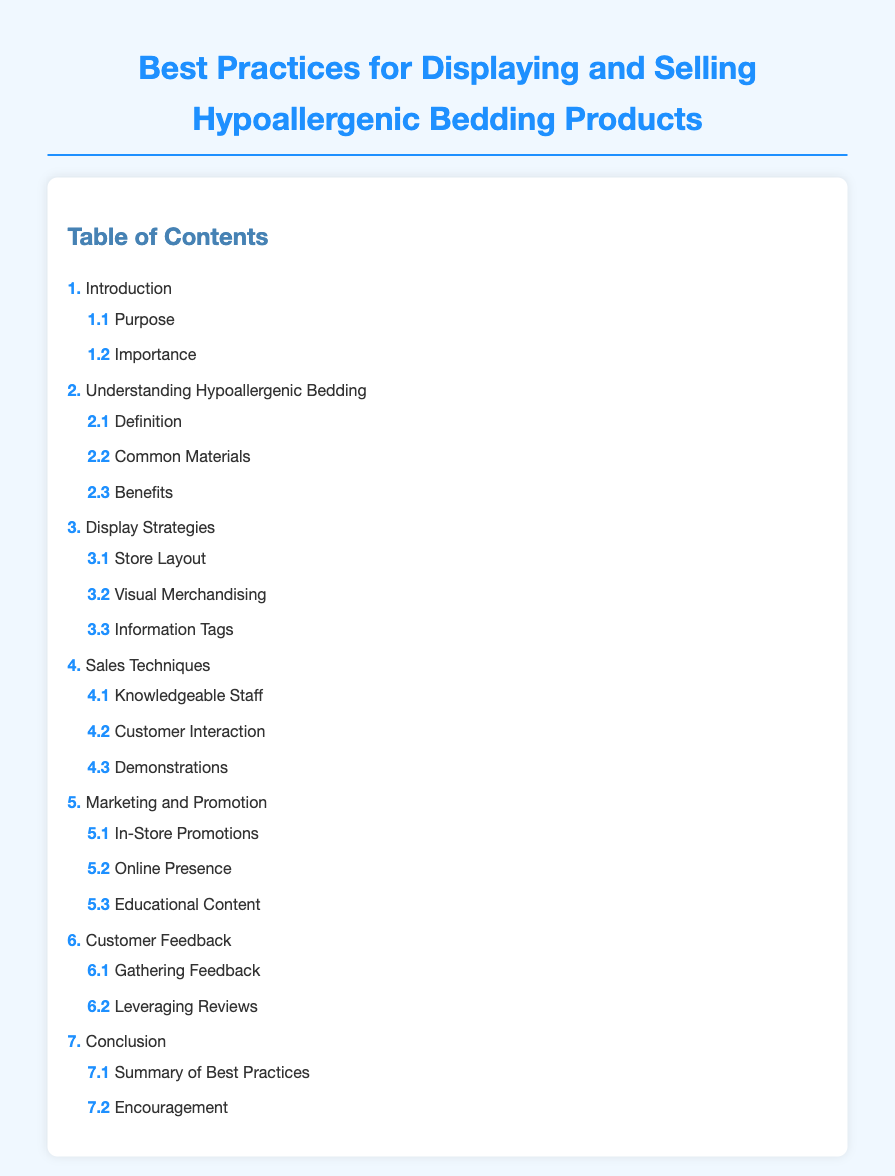what is the title of the document? The title of the document is presented at the top of the rendered HTML page.
Answer: Best Practices for Displaying and Selling Hypoallergenic Bedding Products how many main sections are listed in the table of contents? The number of main sections can be counted from the list in the Table of Contents.
Answer: 7 what is the first subsection under the Introduction section? The first subsection can be found by looking under the Introduction section in the Table of Contents.
Answer: Purpose which section discusses Visual Merchandising? The section that addresses Visual Merchandising is clearly labeled in the Table of Contents.
Answer: Display Strategies what is the last subsection in the Conclusion section? The last subsection can be determined by checking the subsections under the Conclusion section in the Table of Contents.
Answer: Encouragement which main section includes information about Customer Feedback? The main section that includes Customer Feedback is identifiable from the Table of Contents.
Answer: 6. Customer Feedback what is the primary purpose of the document? The primary purpose is inferred from the content and the title of the document.
Answer: To improve selling practices for hypoallergenic bedding products 